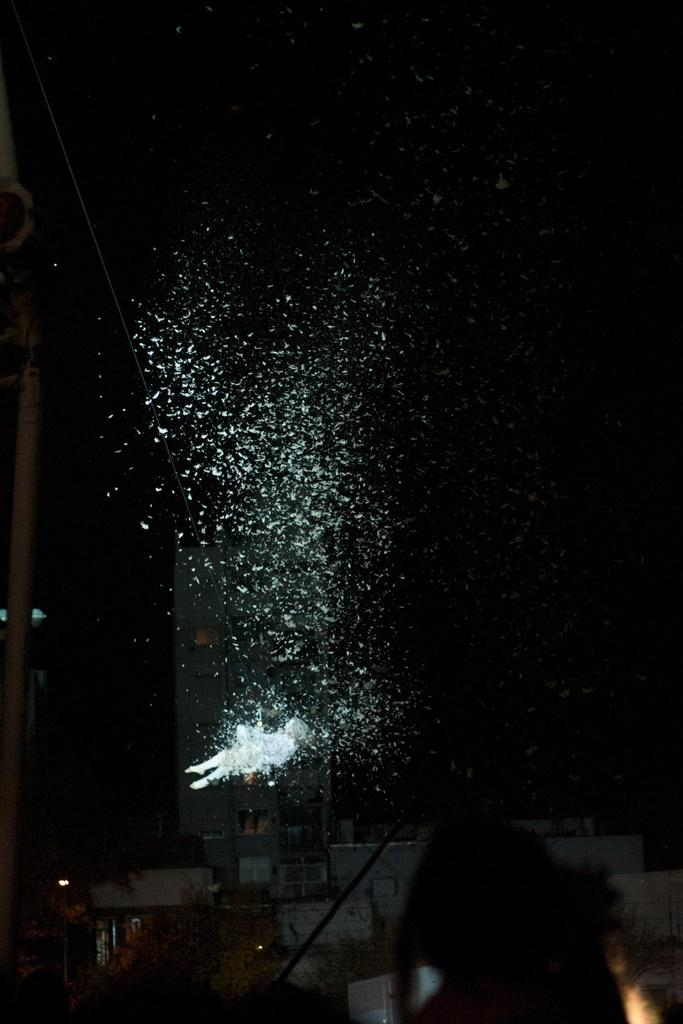What color is the object that is mentioned in the first fact? The object in the image that is mentioned in the first fact is white in color. Are there any other colors present in the image besides white and black? The facts provided only mention white and black objects in the image, so we cannot definitively answer whether there are other colors present. Can you hear the bells ringing in the image? There is no mention of bells in the provided facts, so we cannot answer whether they are present or not. 